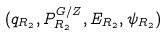Convert formula to latex. <formula><loc_0><loc_0><loc_500><loc_500>( q _ { R _ { 2 } } , P _ { R _ { 2 } } ^ { G / Z } , E _ { R _ { 2 } } , \psi _ { R _ { 2 } } )</formula> 